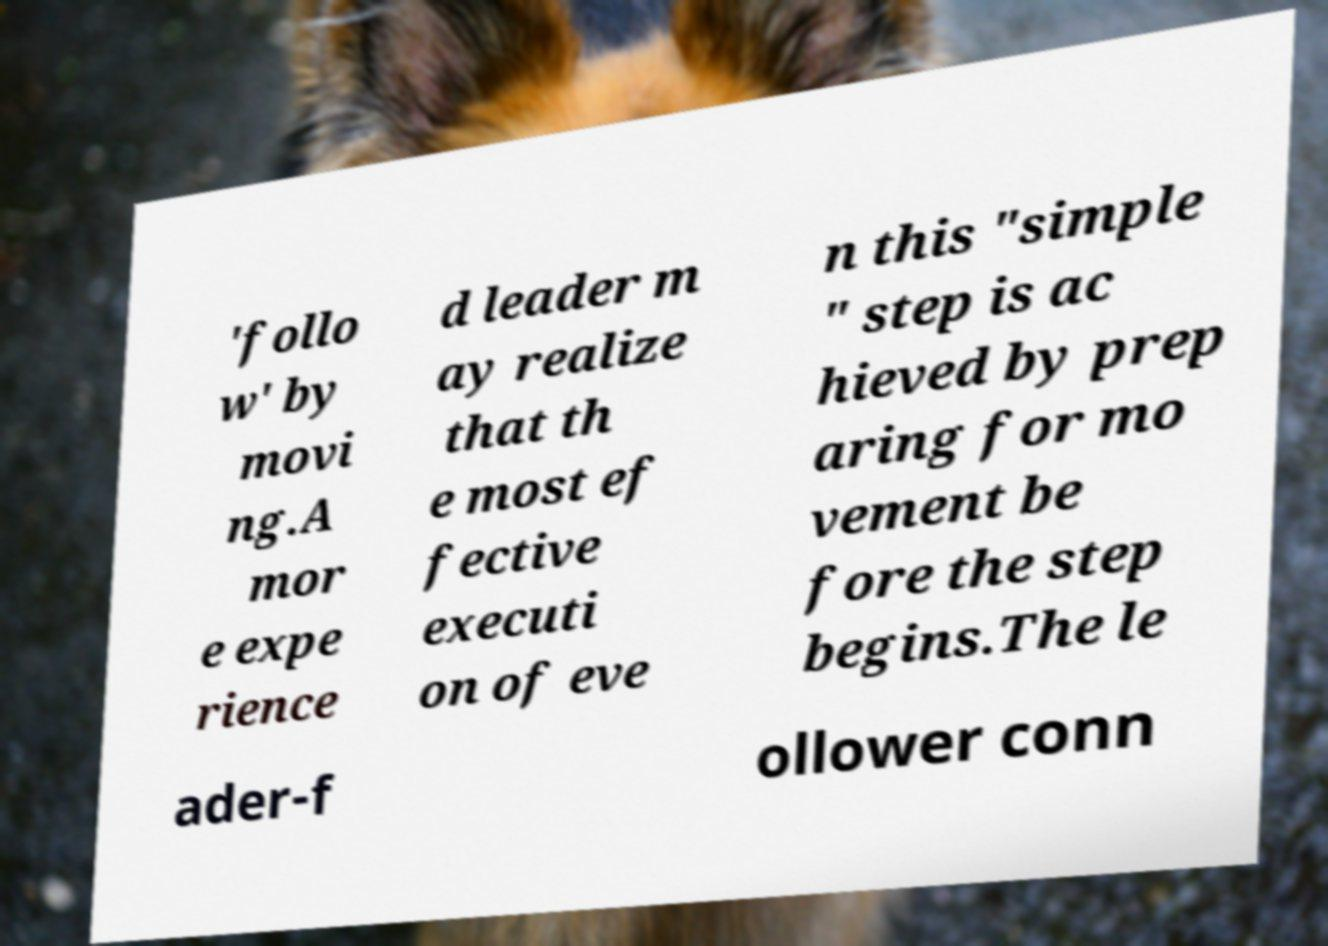Please identify and transcribe the text found in this image. 'follo w' by movi ng.A mor e expe rience d leader m ay realize that th e most ef fective executi on of eve n this "simple " step is ac hieved by prep aring for mo vement be fore the step begins.The le ader-f ollower conn 